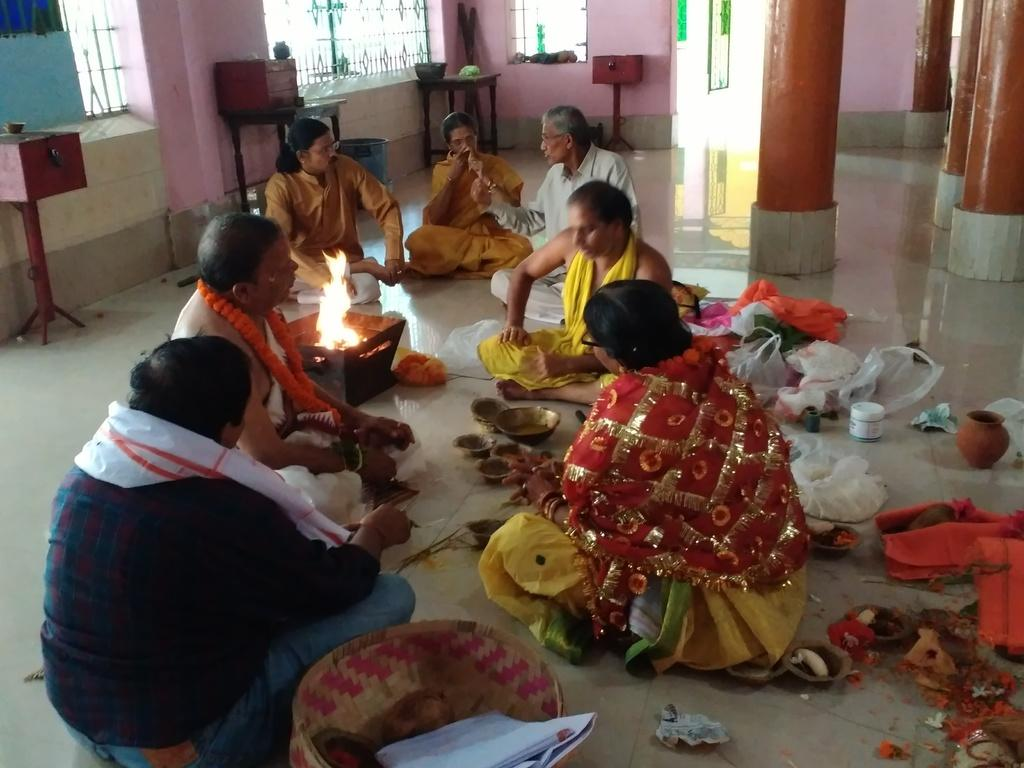How many people are in the image? There is a group of people in the image. What are the people doing in the image? The people are sitting on the floor. What can be seen on the floor in the image? There are many objects placed on the floor. What type of noise can be heard coming from the donkey in the image? There is no donkey present in the image, so it is not possible to determine what, if any, noise might be heard. 